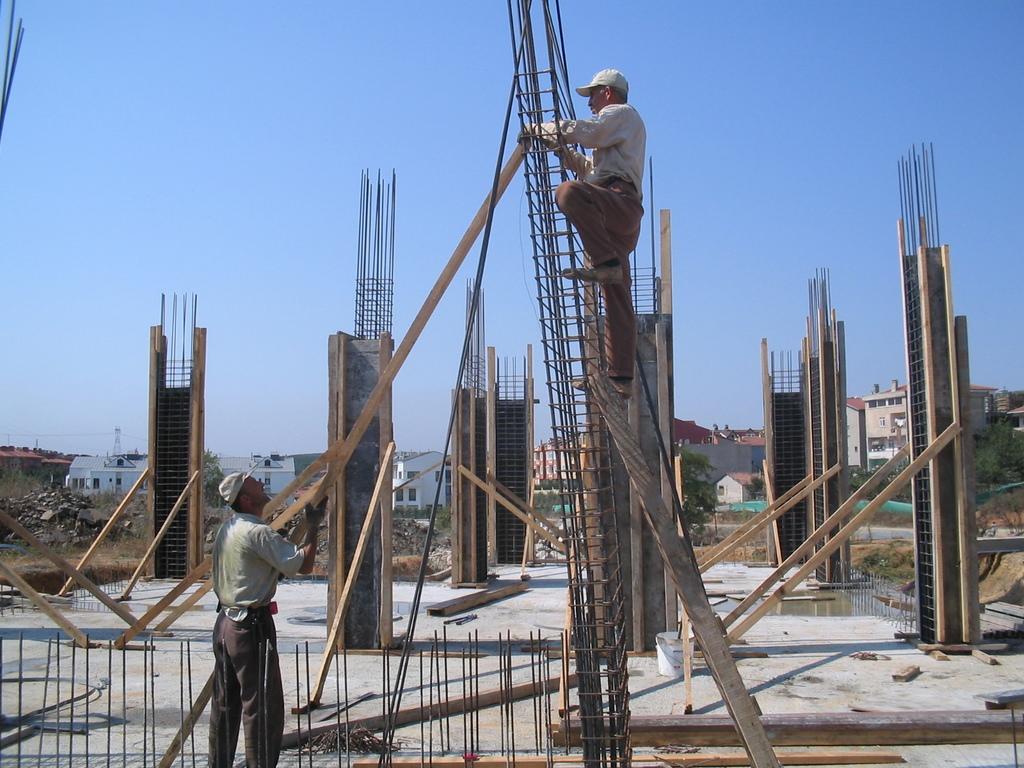Describe this image in one or two sentences. In the image there is In the image there is a man standing on ladder in front of metal pillar and a man holding wooden sheet on the left side, in the back there are pillars and over the background there are buildings and above its sky. 